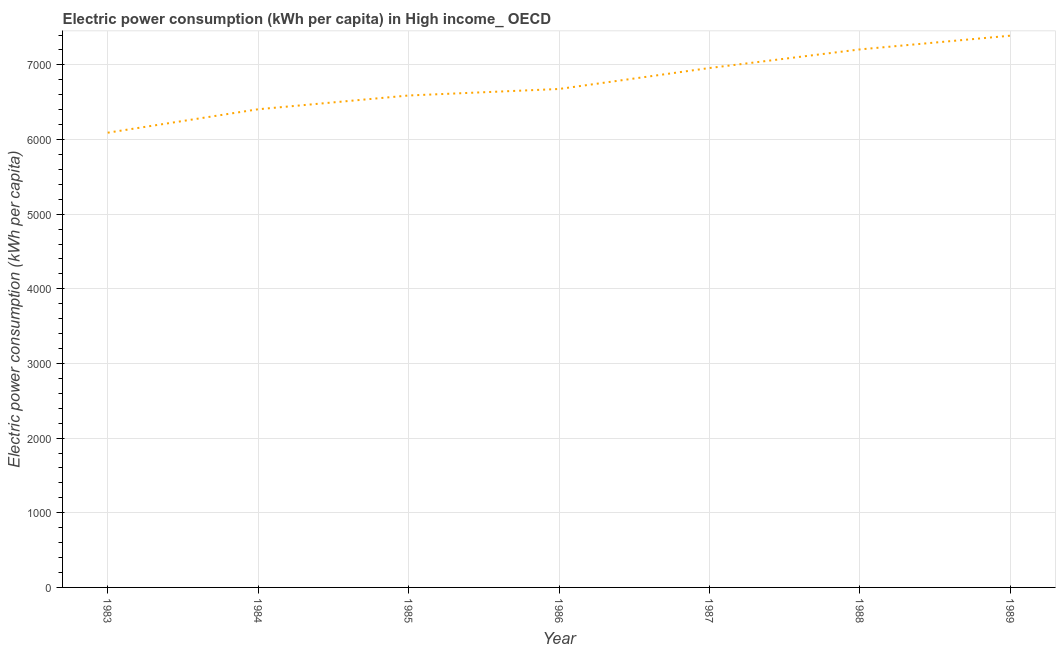What is the electric power consumption in 1984?
Keep it short and to the point. 6405.26. Across all years, what is the maximum electric power consumption?
Give a very brief answer. 7390.95. Across all years, what is the minimum electric power consumption?
Give a very brief answer. 6091.3. In which year was the electric power consumption maximum?
Give a very brief answer. 1989. What is the sum of the electric power consumption?
Give a very brief answer. 4.73e+04. What is the difference between the electric power consumption in 1983 and 1987?
Your answer should be compact. -866.41. What is the average electric power consumption per year?
Make the answer very short. 6759.83. What is the median electric power consumption?
Your answer should be compact. 6676.96. Do a majority of the years between 1985 and 1988 (inclusive) have electric power consumption greater than 800 kWh per capita?
Make the answer very short. Yes. What is the ratio of the electric power consumption in 1984 to that in 1985?
Ensure brevity in your answer.  0.97. What is the difference between the highest and the second highest electric power consumption?
Offer a very short reply. 183.93. Is the sum of the electric power consumption in 1985 and 1988 greater than the maximum electric power consumption across all years?
Provide a succinct answer. Yes. What is the difference between the highest and the lowest electric power consumption?
Ensure brevity in your answer.  1299.66. In how many years, is the electric power consumption greater than the average electric power consumption taken over all years?
Provide a short and direct response. 3. Does the graph contain any zero values?
Offer a very short reply. No. What is the title of the graph?
Provide a short and direct response. Electric power consumption (kWh per capita) in High income_ OECD. What is the label or title of the Y-axis?
Offer a very short reply. Electric power consumption (kWh per capita). What is the Electric power consumption (kWh per capita) of 1983?
Offer a very short reply. 6091.3. What is the Electric power consumption (kWh per capita) of 1984?
Your answer should be very brief. 6405.26. What is the Electric power consumption (kWh per capita) in 1985?
Make the answer very short. 6589.64. What is the Electric power consumption (kWh per capita) of 1986?
Ensure brevity in your answer.  6676.96. What is the Electric power consumption (kWh per capita) in 1987?
Provide a succinct answer. 6957.71. What is the Electric power consumption (kWh per capita) in 1988?
Make the answer very short. 7207.03. What is the Electric power consumption (kWh per capita) in 1989?
Offer a terse response. 7390.95. What is the difference between the Electric power consumption (kWh per capita) in 1983 and 1984?
Your answer should be compact. -313.96. What is the difference between the Electric power consumption (kWh per capita) in 1983 and 1985?
Your answer should be compact. -498.35. What is the difference between the Electric power consumption (kWh per capita) in 1983 and 1986?
Offer a very short reply. -585.66. What is the difference between the Electric power consumption (kWh per capita) in 1983 and 1987?
Provide a short and direct response. -866.41. What is the difference between the Electric power consumption (kWh per capita) in 1983 and 1988?
Offer a very short reply. -1115.73. What is the difference between the Electric power consumption (kWh per capita) in 1983 and 1989?
Provide a succinct answer. -1299.66. What is the difference between the Electric power consumption (kWh per capita) in 1984 and 1985?
Your answer should be very brief. -184.38. What is the difference between the Electric power consumption (kWh per capita) in 1984 and 1986?
Keep it short and to the point. -271.7. What is the difference between the Electric power consumption (kWh per capita) in 1984 and 1987?
Ensure brevity in your answer.  -552.45. What is the difference between the Electric power consumption (kWh per capita) in 1984 and 1988?
Your response must be concise. -801.77. What is the difference between the Electric power consumption (kWh per capita) in 1984 and 1989?
Offer a very short reply. -985.69. What is the difference between the Electric power consumption (kWh per capita) in 1985 and 1986?
Provide a short and direct response. -87.31. What is the difference between the Electric power consumption (kWh per capita) in 1985 and 1987?
Keep it short and to the point. -368.07. What is the difference between the Electric power consumption (kWh per capita) in 1985 and 1988?
Your response must be concise. -617.38. What is the difference between the Electric power consumption (kWh per capita) in 1985 and 1989?
Your answer should be compact. -801.31. What is the difference between the Electric power consumption (kWh per capita) in 1986 and 1987?
Offer a terse response. -280.75. What is the difference between the Electric power consumption (kWh per capita) in 1986 and 1988?
Offer a terse response. -530.07. What is the difference between the Electric power consumption (kWh per capita) in 1986 and 1989?
Give a very brief answer. -714. What is the difference between the Electric power consumption (kWh per capita) in 1987 and 1988?
Give a very brief answer. -249.32. What is the difference between the Electric power consumption (kWh per capita) in 1987 and 1989?
Provide a succinct answer. -433.24. What is the difference between the Electric power consumption (kWh per capita) in 1988 and 1989?
Offer a very short reply. -183.93. What is the ratio of the Electric power consumption (kWh per capita) in 1983 to that in 1984?
Keep it short and to the point. 0.95. What is the ratio of the Electric power consumption (kWh per capita) in 1983 to that in 1985?
Offer a terse response. 0.92. What is the ratio of the Electric power consumption (kWh per capita) in 1983 to that in 1986?
Offer a very short reply. 0.91. What is the ratio of the Electric power consumption (kWh per capita) in 1983 to that in 1988?
Give a very brief answer. 0.84. What is the ratio of the Electric power consumption (kWh per capita) in 1983 to that in 1989?
Offer a terse response. 0.82. What is the ratio of the Electric power consumption (kWh per capita) in 1984 to that in 1987?
Your answer should be very brief. 0.92. What is the ratio of the Electric power consumption (kWh per capita) in 1984 to that in 1988?
Ensure brevity in your answer.  0.89. What is the ratio of the Electric power consumption (kWh per capita) in 1984 to that in 1989?
Provide a short and direct response. 0.87. What is the ratio of the Electric power consumption (kWh per capita) in 1985 to that in 1986?
Provide a short and direct response. 0.99. What is the ratio of the Electric power consumption (kWh per capita) in 1985 to that in 1987?
Keep it short and to the point. 0.95. What is the ratio of the Electric power consumption (kWh per capita) in 1985 to that in 1988?
Provide a short and direct response. 0.91. What is the ratio of the Electric power consumption (kWh per capita) in 1985 to that in 1989?
Your answer should be very brief. 0.89. What is the ratio of the Electric power consumption (kWh per capita) in 1986 to that in 1987?
Offer a terse response. 0.96. What is the ratio of the Electric power consumption (kWh per capita) in 1986 to that in 1988?
Your response must be concise. 0.93. What is the ratio of the Electric power consumption (kWh per capita) in 1986 to that in 1989?
Your response must be concise. 0.9. What is the ratio of the Electric power consumption (kWh per capita) in 1987 to that in 1988?
Offer a terse response. 0.96. What is the ratio of the Electric power consumption (kWh per capita) in 1987 to that in 1989?
Make the answer very short. 0.94. 